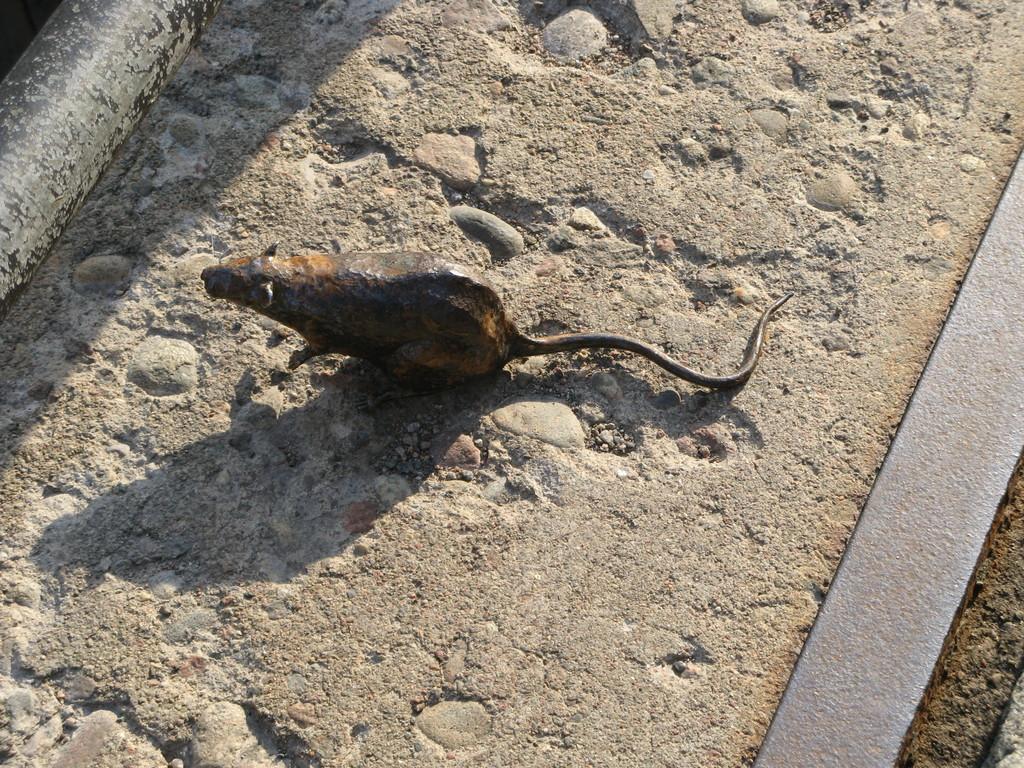Please provide a concise description of this image. In the center of the image we can see a sculpture of a rat. At the bottom there is a road. 